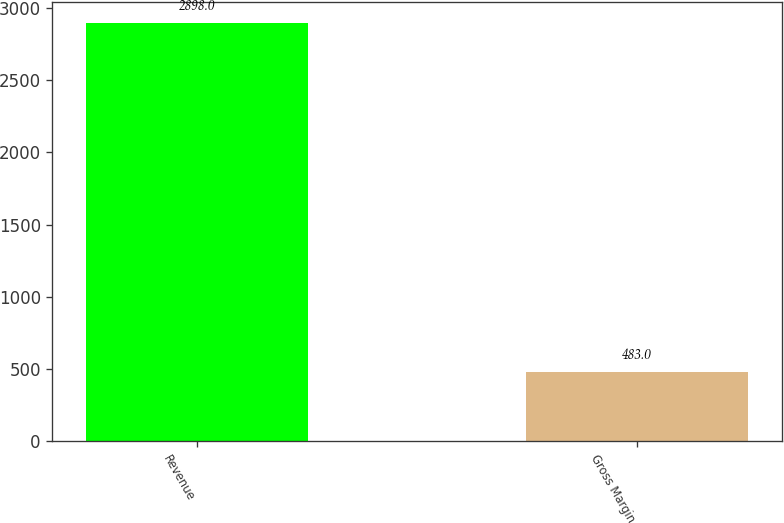Convert chart. <chart><loc_0><loc_0><loc_500><loc_500><bar_chart><fcel>Revenue<fcel>Gross Margin<nl><fcel>2898<fcel>483<nl></chart> 